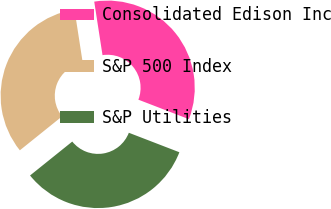<chart> <loc_0><loc_0><loc_500><loc_500><pie_chart><fcel>Consolidated Edison Inc<fcel>S&P 500 Index<fcel>S&P Utilities<nl><fcel>33.3%<fcel>33.33%<fcel>33.37%<nl></chart> 